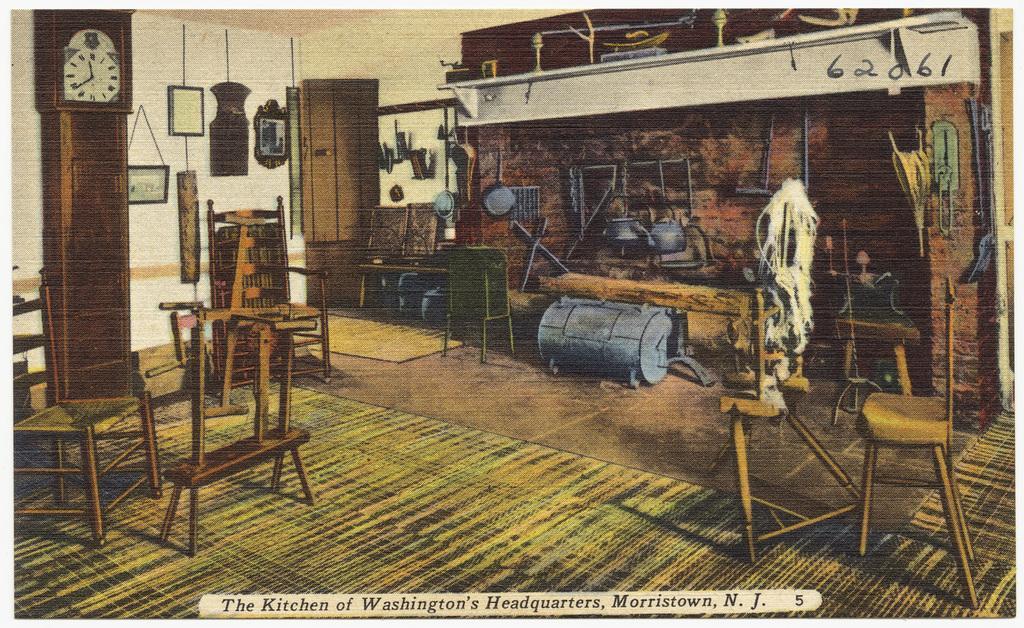How would you summarize this image in a sentence or two? This image is a poster in which there are chairs, wall, door and other objects. At the bottom of the image there is floor. To the left side of the image there is a clock. At the bottom of the image there is text. 